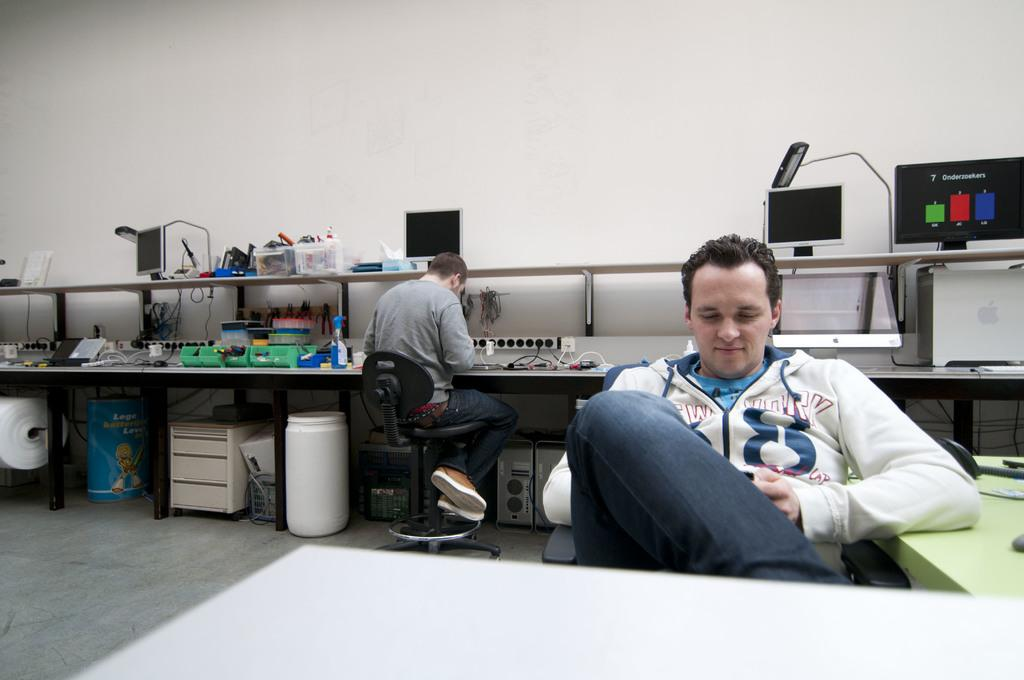How many people are in the image? There are two persons in the image. What are the two persons doing in the image? The two persons are sitting on a chair. What can be seen on the table in the image? There are machines on a table in the image. How many girls are present in the image? The provided facts do not mention the gender of the persons in the image, so it cannot be determined if there are any girls present. What type of alarm can be heard in the image? There is no audible alarm present in the image, as it is a still image and not a video or audio recording. 